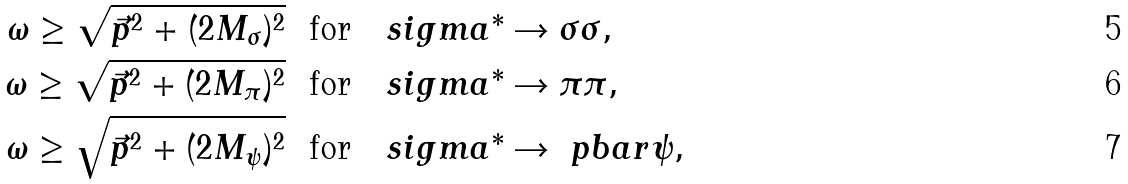Convert formula to latex. <formula><loc_0><loc_0><loc_500><loc_500>\omega \geq \sqrt { \vec { p } ^ { 2 } + ( 2 M _ { \sigma } ) ^ { 2 } } \ \ & \text {for} \ \ \ s i g m a ^ { \ast } \rightarrow \sigma \sigma , \\ \omega \geq \sqrt { \vec { p } ^ { 2 } + ( 2 M _ { \pi } ) ^ { 2 } } \ \ & \text {for} \ \ \ s i g m a ^ { \ast } \rightarrow \pi \pi , \\ \omega \geq \sqrt { \vec { p } ^ { 2 } + ( 2 M _ { \psi } ) ^ { 2 } } \ \ & \text {for} \ \ \ s i g m a ^ { \ast } \rightarrow \ p b a r \psi ,</formula> 